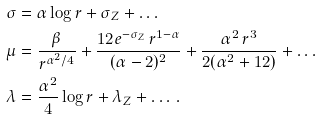<formula> <loc_0><loc_0><loc_500><loc_500>\sigma & = \alpha \log r + \sigma _ { Z } + \dots \\ \mu & = \frac { \beta } { r ^ { \alpha ^ { 2 } / 4 } } + \frac { 1 2 e ^ { - \sigma _ { Z } } \, r ^ { 1 - \alpha } } { ( \alpha - 2 ) ^ { 2 } } + \frac { \alpha ^ { 2 } \, r ^ { 3 } } { 2 ( \alpha ^ { 2 } + 1 2 ) } + \dots \\ \lambda & = \frac { \alpha ^ { 2 } } { 4 } \log r + \lambda _ { Z } + \dots \, .</formula> 